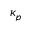<formula> <loc_0><loc_0><loc_500><loc_500>\kappa _ { p }</formula> 